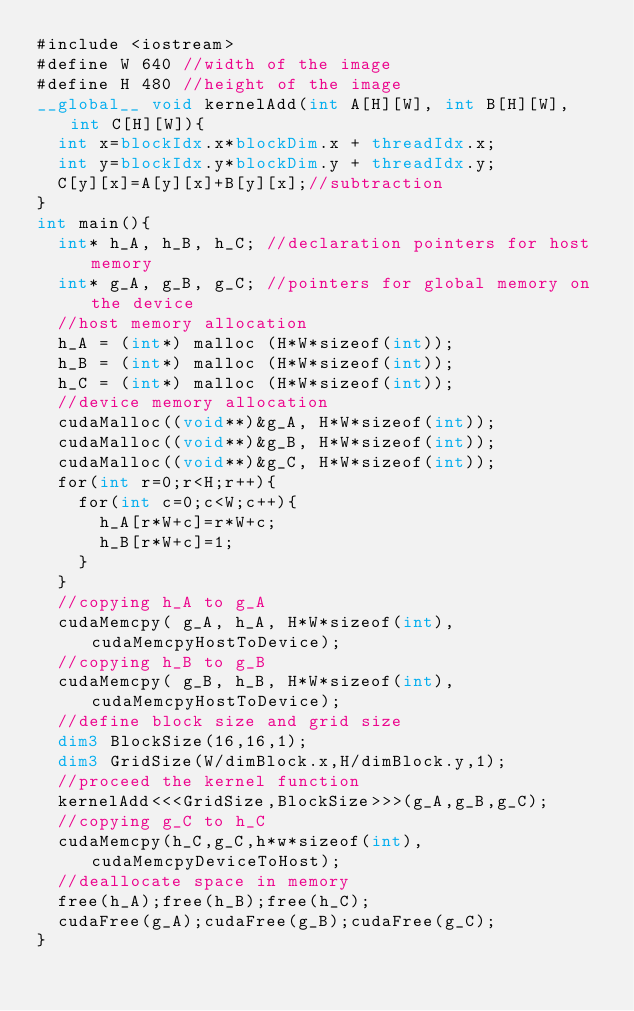<code> <loc_0><loc_0><loc_500><loc_500><_Cuda_>#include <iostream>
#define W 640 //width of the image
#define H 480 //height of the image
__global__ void kernelAdd(int A[H][W], int B[H][W], int C[H][W]){
	int x=blockIdx.x*blockDim.x + threadIdx.x;
	int y=blockIdx.y*blockDim.y + threadIdx.y;
	C[y][x]=A[y][x]+B[y][x];//subtraction
}
int main(){
	int* h_A, h_B, h_C; //declaration pointers for host memory
	int* g_A, g_B, g_C; //pointers for global memory on the device
	//host memory allocation
	h_A = (int*) malloc (H*W*sizeof(int)); 
	h_B = (int*) malloc (H*W*sizeof(int)); 
	h_C = (int*) malloc (H*W*sizeof(int)); 
	//device memory allocation
	cudaMalloc((void**)&g_A, H*W*sizeof(int)); 
	cudaMalloc((void**)&g_B, H*W*sizeof(int));
	cudaMalloc((void**)&g_C, H*W*sizeof(int));
	for(int r=0;r<H;r++){
		for(int c=0;c<W;c++){
			h_A[r*W+c]=r*W+c;
			h_B[r*W+c]=1;
		}
	}		
	//copying h_A to g_A
	cudaMemcpy( g_A, h_A, H*W*sizeof(int),cudaMemcpyHostToDevice);
	//copying h_B to g_B
	cudaMemcpy( g_B, h_B, H*W*sizeof(int),cudaMemcpyHostToDevice);
	//define block size and grid size
	dim3 BlockSize(16,16,1);
	dim3 GridSize(W/dimBlock.x,H/dimBlock.y,1);
	//proceed the kernel function
	kernelAdd<<<GridSize,BlockSize>>>(g_A,g_B,g_C);
	//copying g_C to h_C
	cudaMemcpy(h_C,g_C,h*w*sizeof(int),cudaMemcpyDeviceToHost);
	//deallocate space in memory
	free(h_A);free(h_B);free(h_C);
	cudaFree(g_A);cudaFree(g_B);cudaFree(g_C);
}</code> 